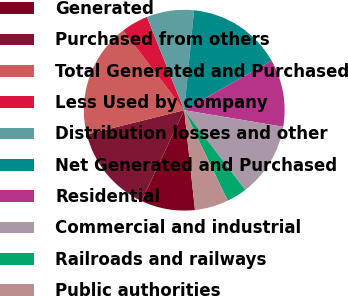Convert chart. <chart><loc_0><loc_0><loc_500><loc_500><pie_chart><fcel>Generated<fcel>Purchased from others<fcel>Total Generated and Purchased<fcel>Less Used by company<fcel>Distribution losses and other<fcel>Net Generated and Purchased<fcel>Residential<fcel>Commercial and industrial<fcel>Railroads and railways<fcel>Public authorities<nl><fcel>8.7%<fcel>14.13%<fcel>18.48%<fcel>4.35%<fcel>7.61%<fcel>15.22%<fcel>10.87%<fcel>11.96%<fcel>3.26%<fcel>5.43%<nl></chart> 